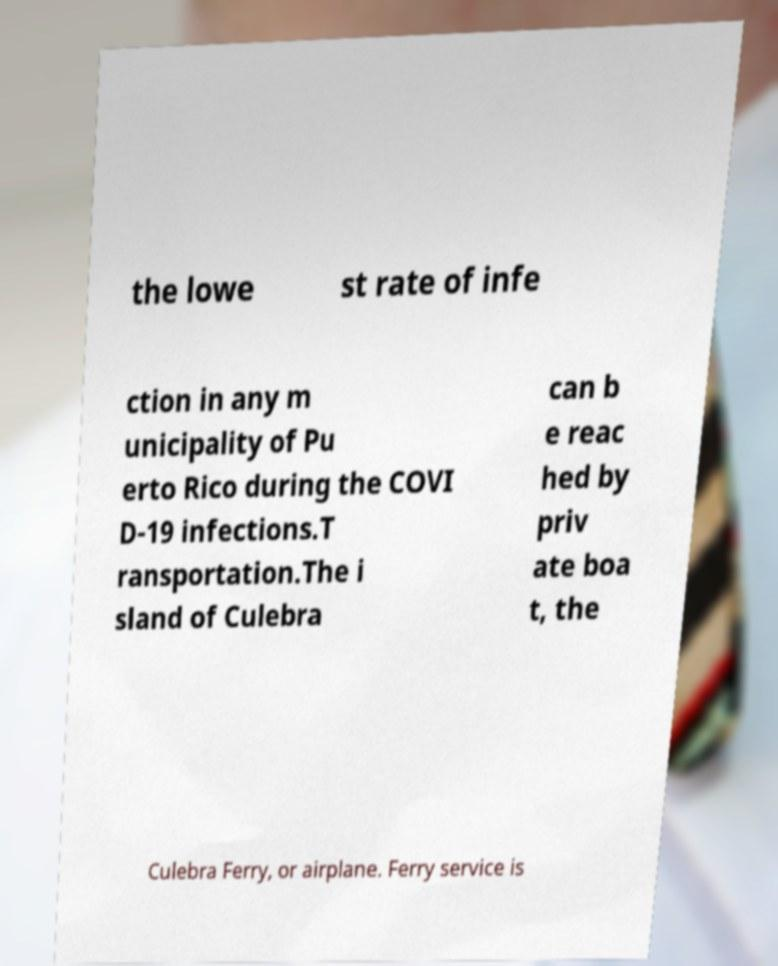Can you read and provide the text displayed in the image?This photo seems to have some interesting text. Can you extract and type it out for me? the lowe st rate of infe ction in any m unicipality of Pu erto Rico during the COVI D-19 infections.T ransportation.The i sland of Culebra can b e reac hed by priv ate boa t, the Culebra Ferry, or airplane. Ferry service is 